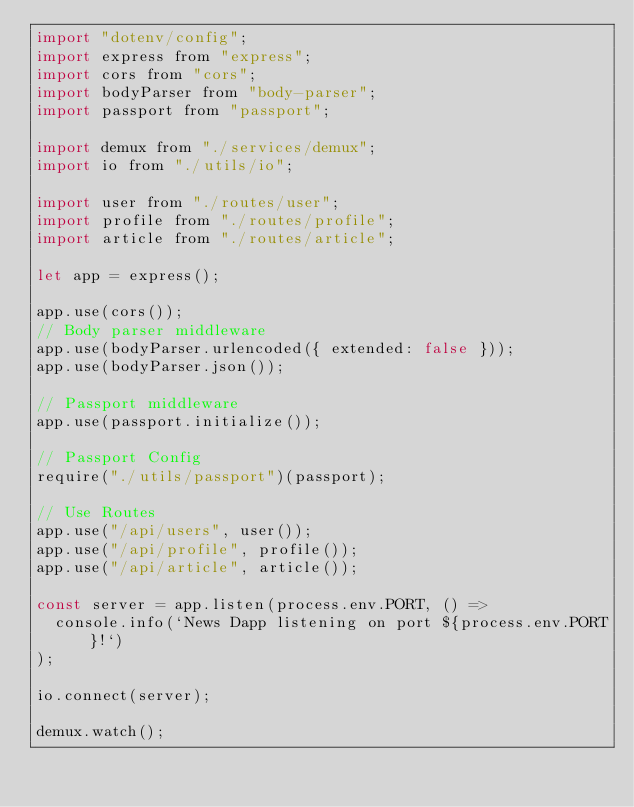<code> <loc_0><loc_0><loc_500><loc_500><_JavaScript_>import "dotenv/config";
import express from "express";
import cors from "cors";
import bodyParser from "body-parser";
import passport from "passport";

import demux from "./services/demux";
import io from "./utils/io";

import user from "./routes/user";
import profile from "./routes/profile";
import article from "./routes/article";

let app = express();

app.use(cors());
// Body parser middleware
app.use(bodyParser.urlencoded({ extended: false }));
app.use(bodyParser.json());

// Passport middleware
app.use(passport.initialize());

// Passport Config
require("./utils/passport")(passport);

// Use Routes
app.use("/api/users", user());
app.use("/api/profile", profile());
app.use("/api/article", article());

const server = app.listen(process.env.PORT, () =>
  console.info(`News Dapp listening on port ${process.env.PORT}!`)
);

io.connect(server);

demux.watch();
</code> 